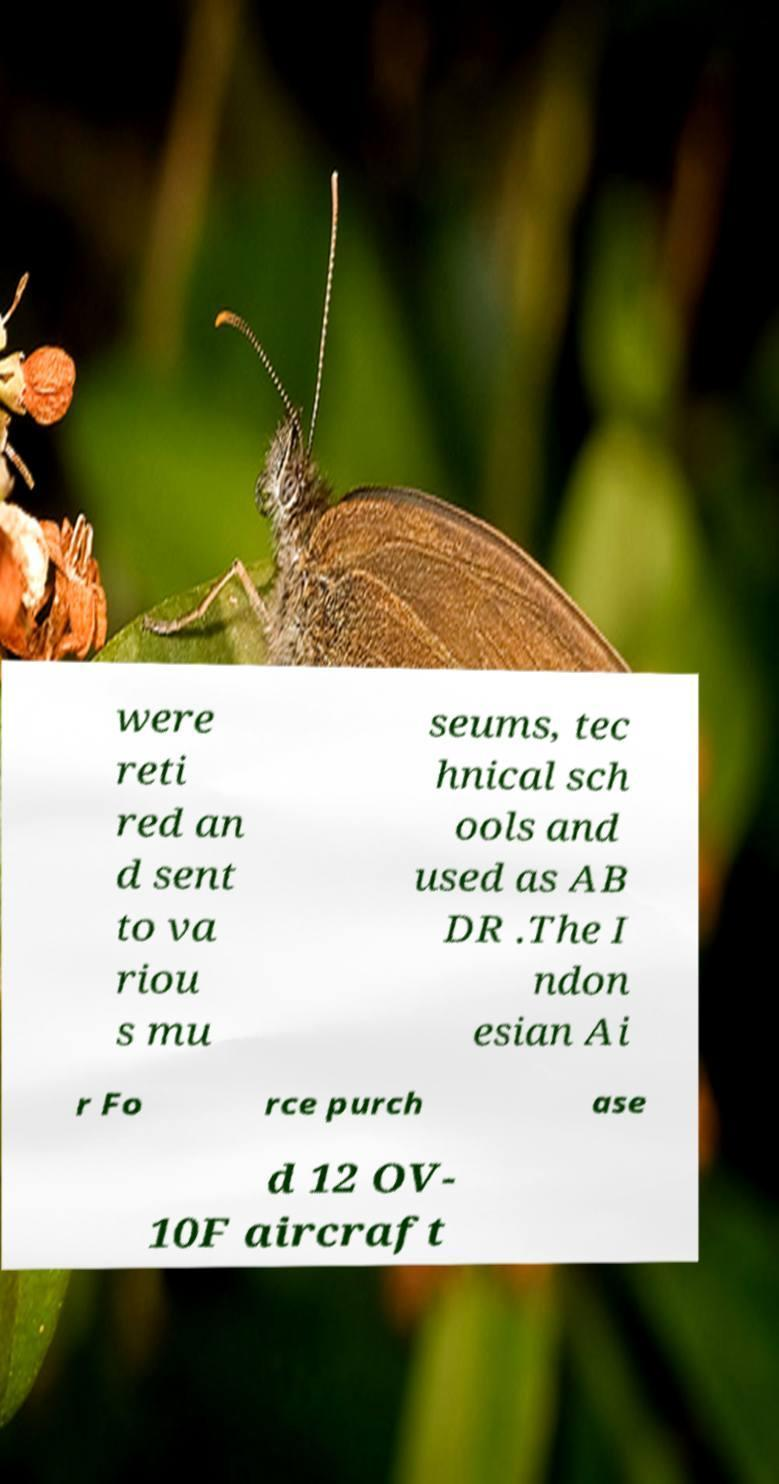Please identify and transcribe the text found in this image. were reti red an d sent to va riou s mu seums, tec hnical sch ools and used as AB DR .The I ndon esian Ai r Fo rce purch ase d 12 OV- 10F aircraft 